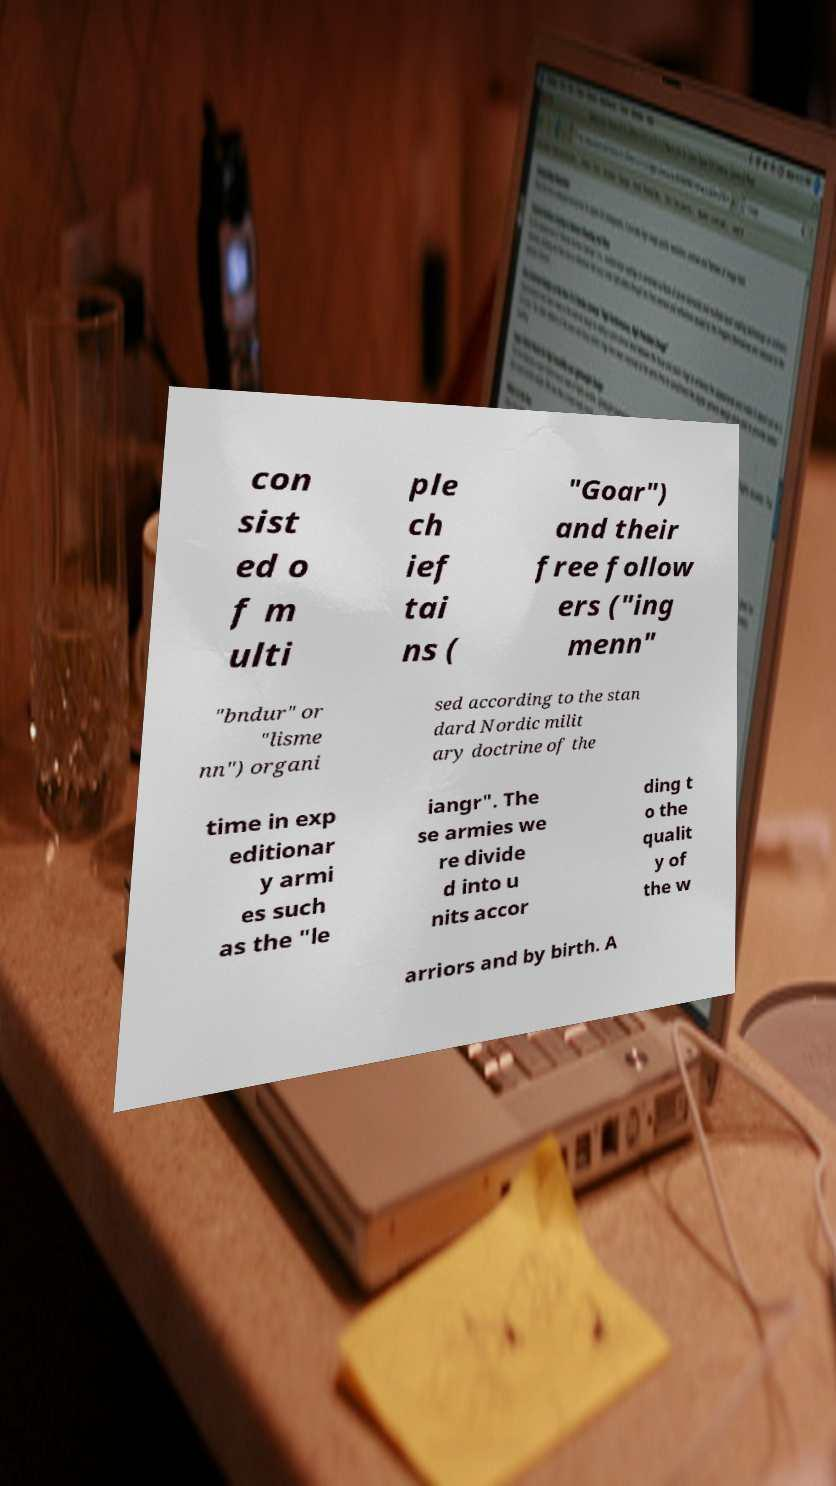Could you extract and type out the text from this image? con sist ed o f m ulti ple ch ief tai ns ( "Goar") and their free follow ers ("ing menn" "bndur" or "lisme nn") organi sed according to the stan dard Nordic milit ary doctrine of the time in exp editionar y armi es such as the "le iangr". The se armies we re divide d into u nits accor ding t o the qualit y of the w arriors and by birth. A 